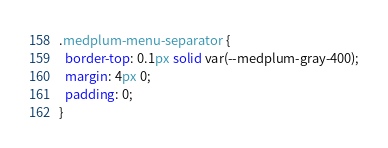<code> <loc_0><loc_0><loc_500><loc_500><_CSS_>.medplum-menu-separator {
  border-top: 0.1px solid var(--medplum-gray-400);
  margin: 4px 0;
  padding: 0;
}
</code> 